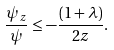<formula> <loc_0><loc_0><loc_500><loc_500>\frac { \psi _ { z } } { \psi } \leq - \frac { ( 1 + \lambda ) } { 2 z } .</formula> 